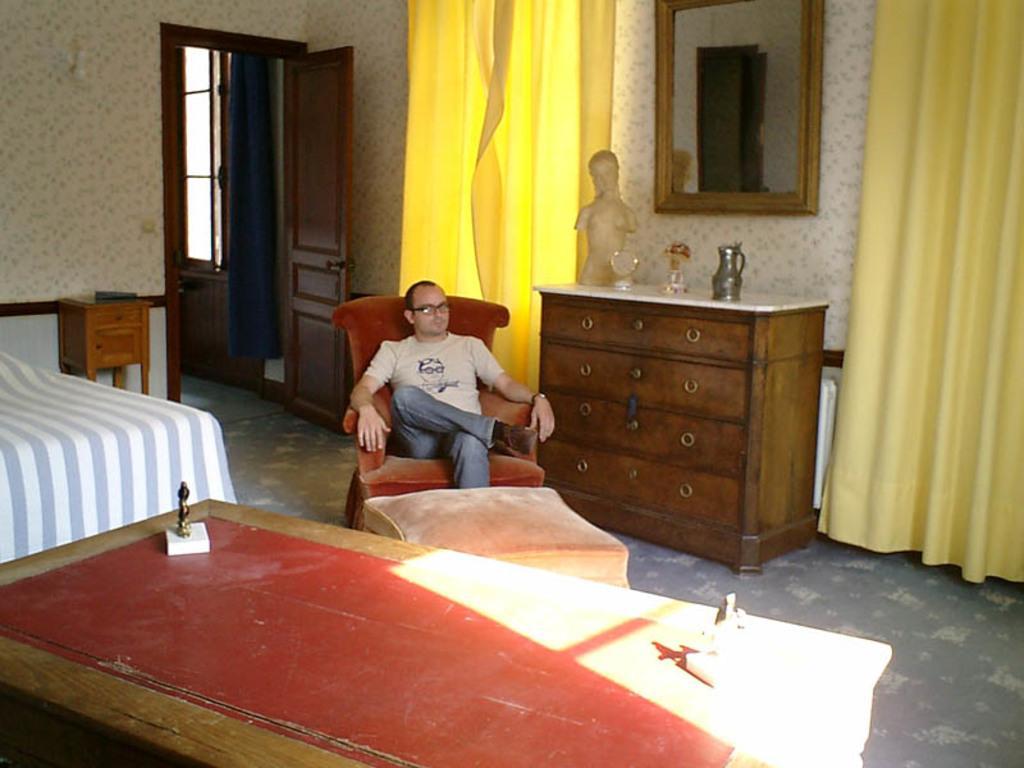How would you summarize this image in a sentence or two? In the image we can see there is a man who is sitting on chair and there is a bed and table on which there are two statues of a person. 